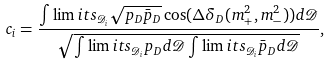<formula> <loc_0><loc_0><loc_500><loc_500>c _ { i } = \frac { \int \lim i t s _ { \mathcal { D } _ { i } } \sqrt { p _ { D } \bar { p } _ { D } } \cos ( \Delta \delta _ { D } ( m ^ { 2 } _ { + } , m ^ { 2 } _ { - } ) ) d \mathcal { D } } { \sqrt { \int \lim i t s _ { \mathcal { D } _ { i } } p _ { D } d \mathcal { D } \int \lim i t s _ { \mathcal { D } _ { i } } \bar { p } _ { D } d \mathcal { D } } } ,</formula> 